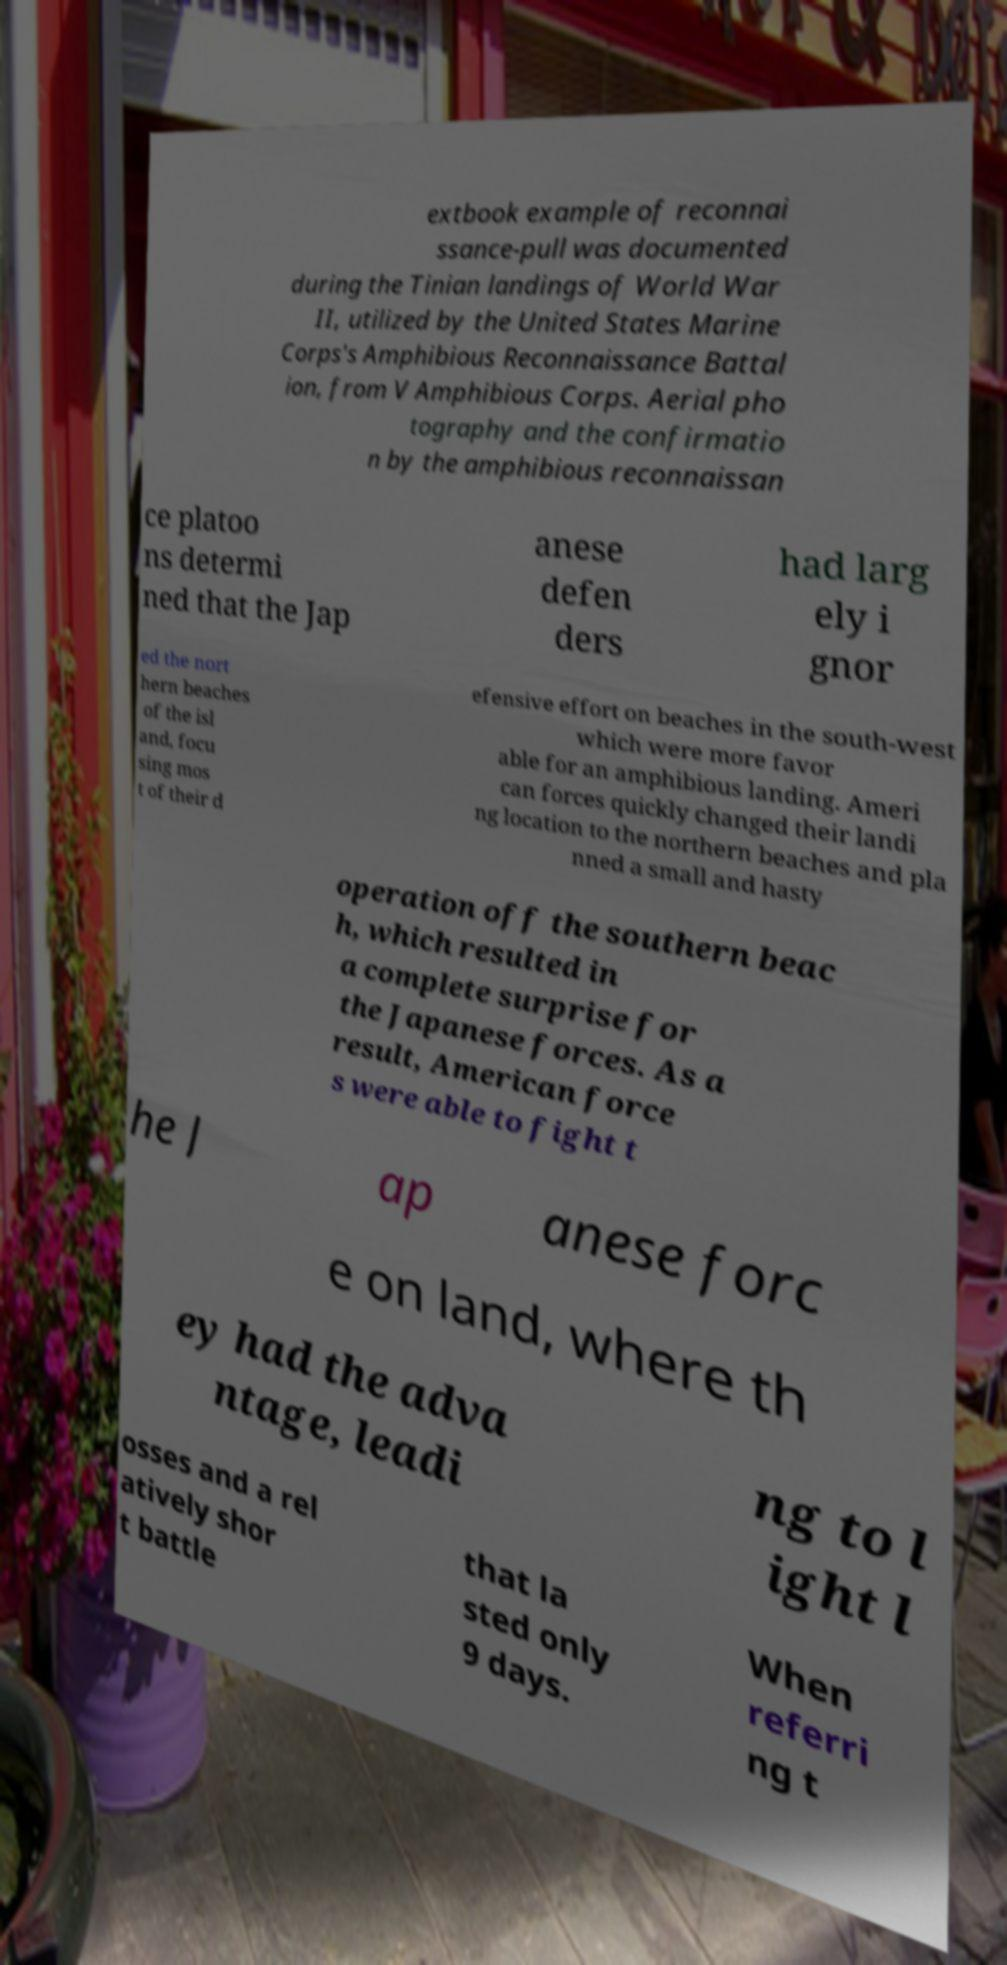What messages or text are displayed in this image? I need them in a readable, typed format. extbook example of reconnai ssance-pull was documented during the Tinian landings of World War II, utilized by the United States Marine Corps's Amphibious Reconnaissance Battal ion, from V Amphibious Corps. Aerial pho tography and the confirmatio n by the amphibious reconnaissan ce platoo ns determi ned that the Jap anese defen ders had larg ely i gnor ed the nort hern beaches of the isl and, focu sing mos t of their d efensive effort on beaches in the south-west which were more favor able for an amphibious landing. Ameri can forces quickly changed their landi ng location to the northern beaches and pla nned a small and hasty operation off the southern beac h, which resulted in a complete surprise for the Japanese forces. As a result, American force s were able to fight t he J ap anese forc e on land, where th ey had the adva ntage, leadi ng to l ight l osses and a rel atively shor t battle that la sted only 9 days. When referri ng t 